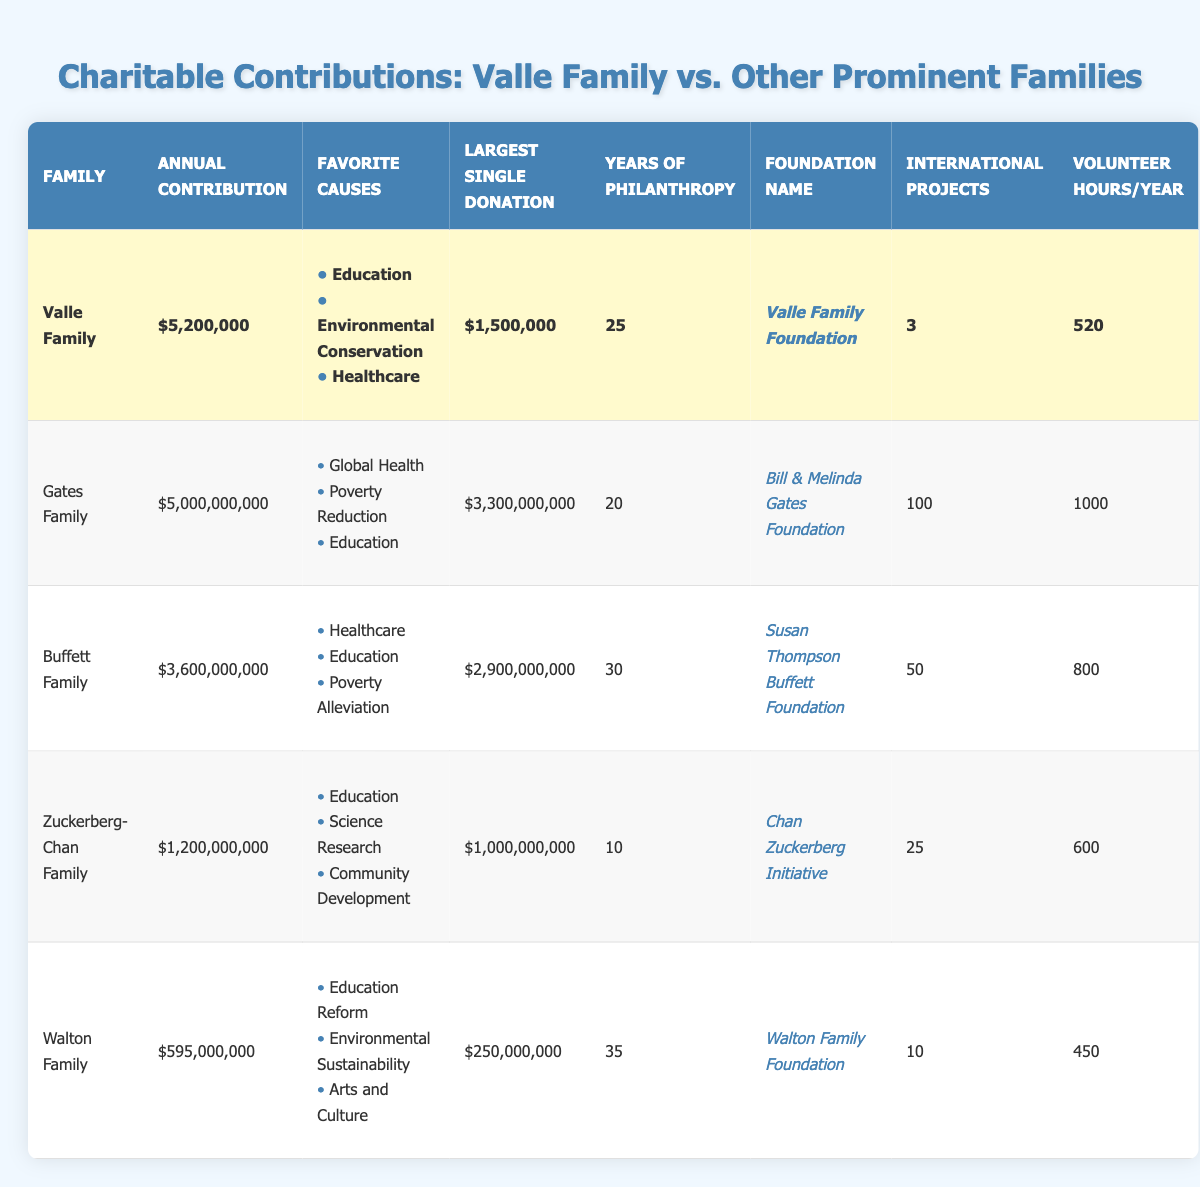What is the annual contribution of the Valle Family? The annual contribution of the Valle Family can be found directly in the table under the "Annual Contribution" column, which states "$5,200,000".
Answer: $5,200,000 How many international projects has the Valle Family sponsored? The "International Projects" column indicates that the Valle Family has sponsored 3 international projects.
Answer: 3 Which family has the highest largest single donation? By comparing the "Largest Single Donation" column, the Gates Family has the highest amount at "$3,300,000,000".
Answer: Gates Family What is the difference between the annual contributions of the Gates Family and the Valle Family? The annual contribution of the Gates Family is "$5,000,000,000" and the Valle Family's is "$5,200,000". The difference is calculated as follows: $5,000,000,000 - $5,200,000 = $4,994,800,000.
Answer: $4,994,800,000 How many years of philanthropy does the Buffett Family have? The table indicates that the Buffett Family has been involved in philanthropy for 30 years, found in the "Years of Philanthropy" column.
Answer: 30 Is the Valle Family's largest single donation greater than the Zuckerberg-Chan Family's? The largest single donation for the Valle Family is "$1,500,000", while the Zuckerberg-Chan Family's is "$1,000,000,000". Since "$1,500,000" is less than "$1,000,000,000", the statement is false.
Answer: No What is the average annual contribution of the listed families? To calculate the average, add all annual contributions: $5,200,000 + $5,000,000,000 + $3,600,000,000 + $1,200,000,000 + $595,000,000 = $10,400,200,000. Divide by the number of families (5): $10,400,200,000 / 5 = $2,080,040,000.
Answer: $2,080,040,000 Which family has the least volunteer hours per year? Comparing the "Volunteer Hours/Year" column, the Walton Family has the least with 450 hours, which is lower than the others listed.
Answer: Walton Family Does the Valle Family focus on Education as one of its favorite causes? Looking at the "Favorite Causes" column for the Valle Family, Education is indeed listed as one of their top causes, confirming that it is true.
Answer: Yes 